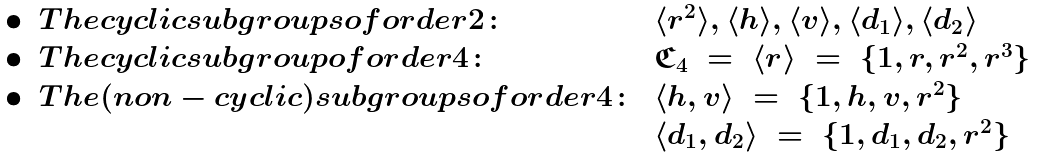Convert formula to latex. <formula><loc_0><loc_0><loc_500><loc_500>\begin{array} { c l l } \bullet & T h e c y c l i c s u b g r o u p s o f o r d e r 2 \colon & \langle r ^ { 2 } \rangle , \langle h \rangle , \langle v \rangle , \langle d _ { 1 } \rangle , \langle d _ { 2 } \rangle \\ \bullet & T h e c y c l i c s u b g r o u p o f o r d e r 4 \colon & \mathfrak { C } _ { 4 } \ = \ \langle r \rangle \ = \ \{ 1 , r , r ^ { 2 } , r ^ { 3 } \} \\ \bullet & T h e ( n o n - c y c l i c ) s u b g r o u p s o f o r d e r 4 \colon & \langle h , v \rangle \ = \ \{ 1 , h , v , r ^ { 2 } \} \\ & & \langle d _ { 1 } , d _ { 2 } \rangle \ = \ \{ 1 , d _ { 1 } , d _ { 2 } , r ^ { 2 } \} \end{array}</formula> 